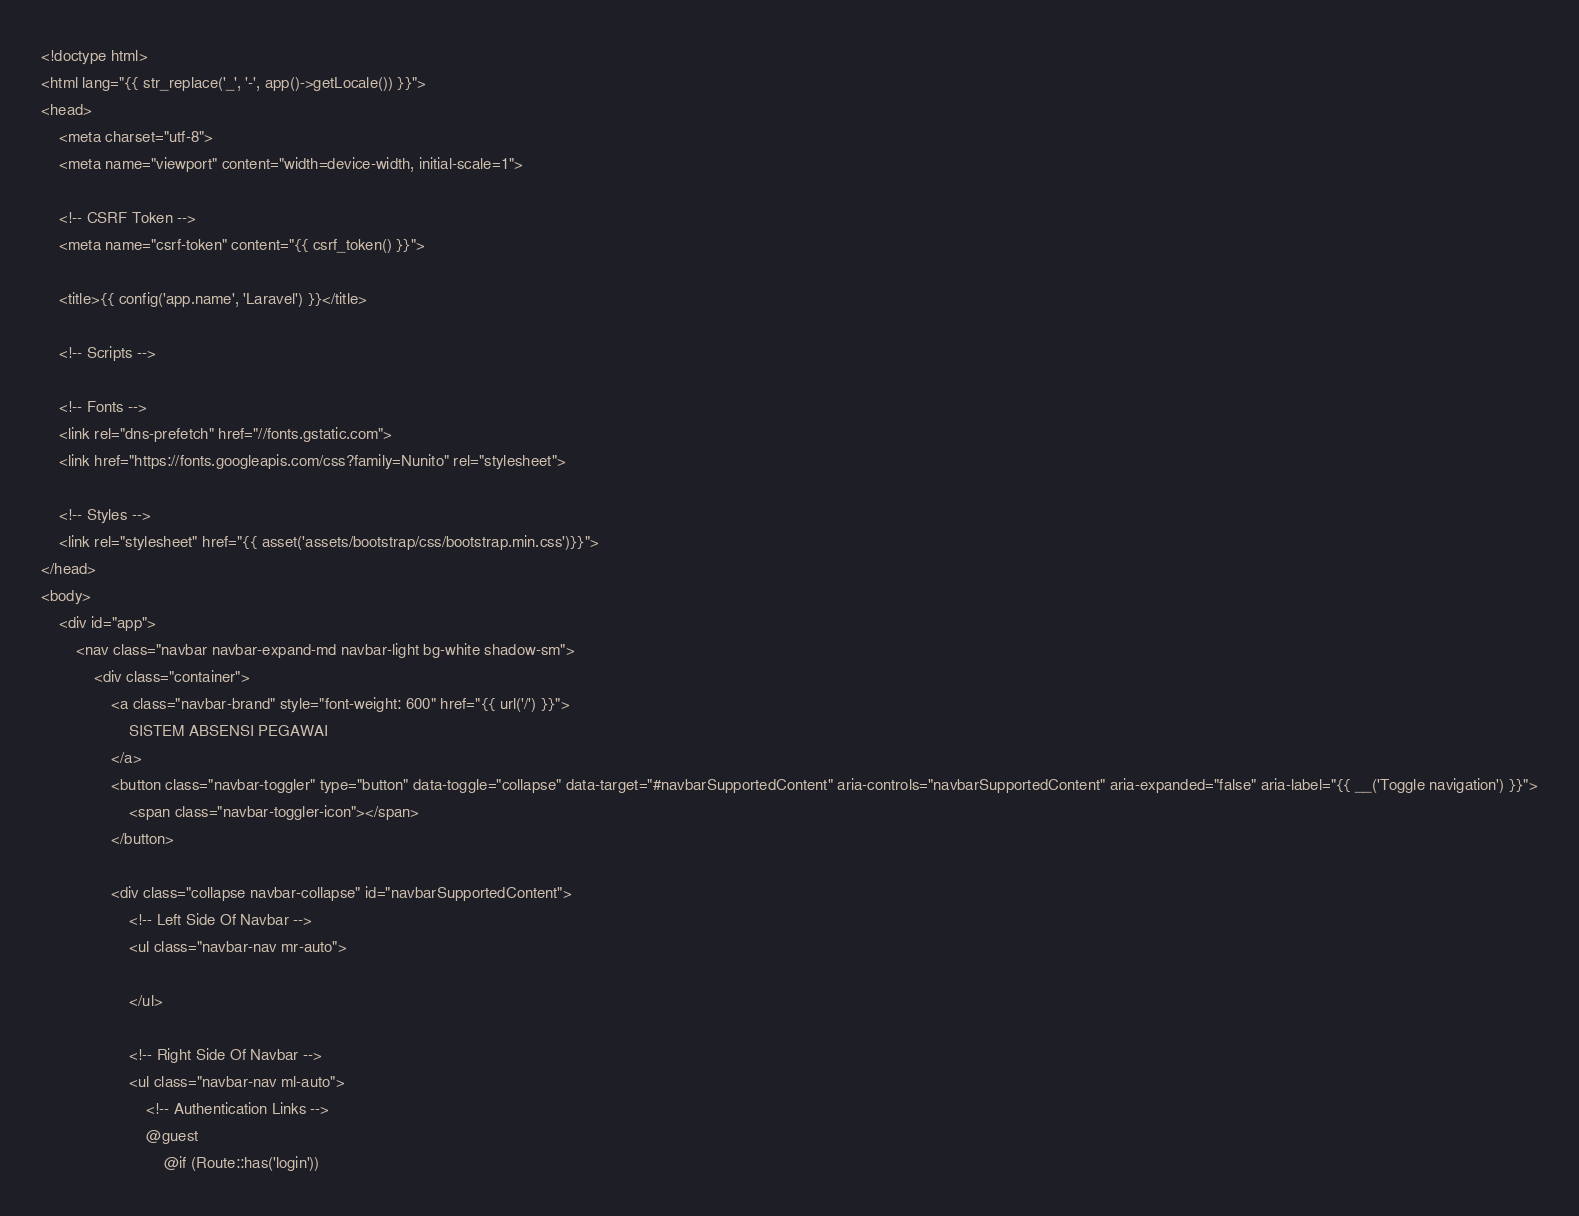Convert code to text. <code><loc_0><loc_0><loc_500><loc_500><_PHP_><!doctype html>
<html lang="{{ str_replace('_', '-', app()->getLocale()) }}">
<head>
    <meta charset="utf-8">
    <meta name="viewport" content="width=device-width, initial-scale=1">

    <!-- CSRF Token -->
    <meta name="csrf-token" content="{{ csrf_token() }}">

    <title>{{ config('app.name', 'Laravel') }}</title>

    <!-- Scripts -->
  
    <!-- Fonts -->
    <link rel="dns-prefetch" href="//fonts.gstatic.com">
    <link href="https://fonts.googleapis.com/css?family=Nunito" rel="stylesheet">

    <!-- Styles -->
    <link rel="stylesheet" href="{{ asset('assets/bootstrap/css/bootstrap.min.css')}}"> 
</head>
<body>
    <div id="app">
        <nav class="navbar navbar-expand-md navbar-light bg-white shadow-sm">
            <div class="container">
                <a class="navbar-brand" style="font-weight: 600" href="{{ url('/') }}">
                    SISTEM ABSENSI PEGAWAI
                </a>
                <button class="navbar-toggler" type="button" data-toggle="collapse" data-target="#navbarSupportedContent" aria-controls="navbarSupportedContent" aria-expanded="false" aria-label="{{ __('Toggle navigation') }}">
                    <span class="navbar-toggler-icon"></span>
                </button>

                <div class="collapse navbar-collapse" id="navbarSupportedContent">
                    <!-- Left Side Of Navbar -->
                    <ul class="navbar-nav mr-auto">

                    </ul>

                    <!-- Right Side Of Navbar -->
                    <ul class="navbar-nav ml-auto">
                        <!-- Authentication Links -->
                        @guest
                            @if (Route::has('login'))</code> 